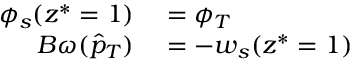<formula> <loc_0><loc_0><loc_500><loc_500>\begin{array} { r l } { \phi _ { s } ( z ^ { * } = 1 ) } & = \phi _ { T } } \\ { B \omega ( \hat { p } _ { T } ) } & = - w _ { s } ( z ^ { * } = 1 ) } \end{array}</formula> 